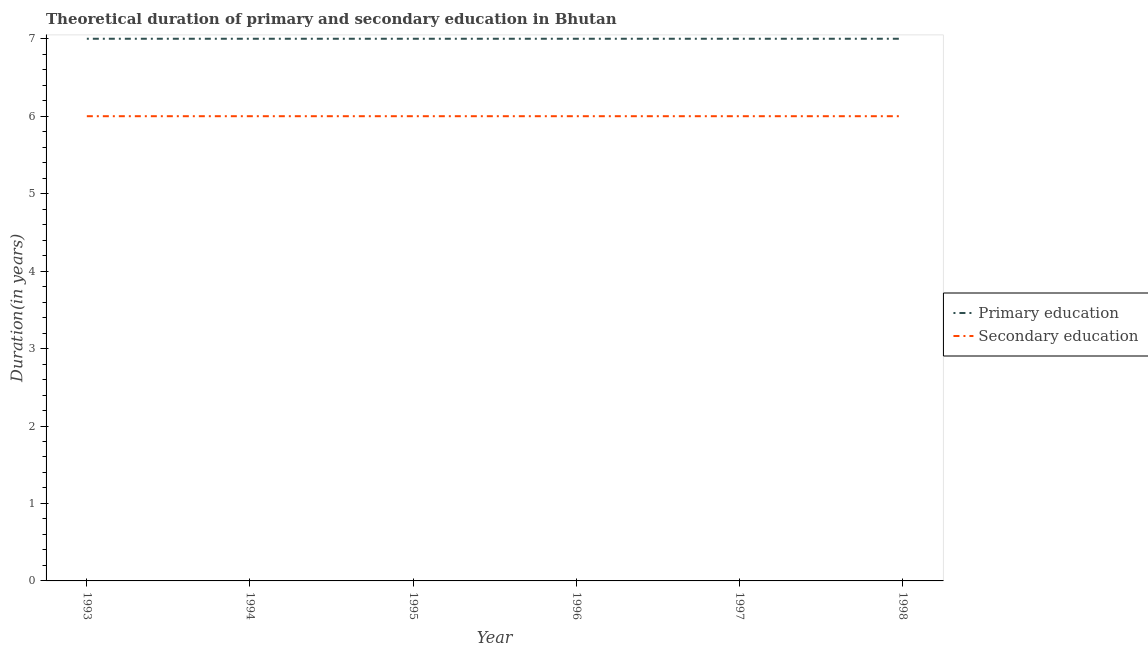How many different coloured lines are there?
Provide a succinct answer. 2. Does the line corresponding to duration of secondary education intersect with the line corresponding to duration of primary education?
Make the answer very short. No. What is the duration of primary education in 1996?
Make the answer very short. 7. In which year was the duration of primary education maximum?
Offer a very short reply. 1993. In which year was the duration of primary education minimum?
Provide a short and direct response. 1993. What is the total duration of primary education in the graph?
Keep it short and to the point. 42. What is the difference between the duration of primary education in 1996 and the duration of secondary education in 1998?
Your answer should be very brief. 1. What is the average duration of secondary education per year?
Your answer should be compact. 6. In the year 1998, what is the difference between the duration of primary education and duration of secondary education?
Make the answer very short. 1. What is the ratio of the duration of primary education in 1995 to that in 1998?
Keep it short and to the point. 1. Is the duration of primary education in 1996 less than that in 1997?
Offer a terse response. No. In how many years, is the duration of primary education greater than the average duration of primary education taken over all years?
Keep it short and to the point. 0. Is the sum of the duration of secondary education in 1993 and 1998 greater than the maximum duration of primary education across all years?
Give a very brief answer. Yes. Does the duration of primary education monotonically increase over the years?
Make the answer very short. No. How many lines are there?
Keep it short and to the point. 2. What is the difference between two consecutive major ticks on the Y-axis?
Provide a succinct answer. 1. Are the values on the major ticks of Y-axis written in scientific E-notation?
Make the answer very short. No. Does the graph contain any zero values?
Make the answer very short. No. Does the graph contain grids?
Provide a succinct answer. No. What is the title of the graph?
Provide a succinct answer. Theoretical duration of primary and secondary education in Bhutan. What is the label or title of the X-axis?
Your answer should be compact. Year. What is the label or title of the Y-axis?
Give a very brief answer. Duration(in years). What is the Duration(in years) of Secondary education in 1993?
Give a very brief answer. 6. What is the Duration(in years) of Primary education in 1994?
Keep it short and to the point. 7. What is the Duration(in years) of Primary education in 1995?
Your answer should be compact. 7. What is the Duration(in years) in Secondary education in 1995?
Offer a terse response. 6. What is the Duration(in years) in Primary education in 1997?
Your response must be concise. 7. Across all years, what is the minimum Duration(in years) of Secondary education?
Your response must be concise. 6. What is the total Duration(in years) in Secondary education in the graph?
Your answer should be very brief. 36. What is the difference between the Duration(in years) of Primary education in 1993 and that in 1994?
Make the answer very short. 0. What is the difference between the Duration(in years) of Primary education in 1993 and that in 1996?
Offer a very short reply. 0. What is the difference between the Duration(in years) of Secondary education in 1993 and that in 1996?
Provide a succinct answer. 0. What is the difference between the Duration(in years) of Secondary education in 1993 and that in 1997?
Your answer should be compact. 0. What is the difference between the Duration(in years) of Primary education in 1993 and that in 1998?
Your answer should be compact. 0. What is the difference between the Duration(in years) of Primary education in 1994 and that in 1995?
Keep it short and to the point. 0. What is the difference between the Duration(in years) of Secondary education in 1994 and that in 1995?
Your answer should be very brief. 0. What is the difference between the Duration(in years) of Primary education in 1995 and that in 1997?
Your response must be concise. 0. What is the difference between the Duration(in years) of Primary education in 1995 and that in 1998?
Your response must be concise. 0. What is the difference between the Duration(in years) in Secondary education in 1995 and that in 1998?
Offer a very short reply. 0. What is the difference between the Duration(in years) in Secondary education in 1996 and that in 1997?
Ensure brevity in your answer.  0. What is the difference between the Duration(in years) of Primary education in 1997 and that in 1998?
Offer a very short reply. 0. What is the difference between the Duration(in years) of Primary education in 1993 and the Duration(in years) of Secondary education in 1996?
Your response must be concise. 1. What is the difference between the Duration(in years) of Primary education in 1993 and the Duration(in years) of Secondary education in 1997?
Keep it short and to the point. 1. What is the difference between the Duration(in years) of Primary education in 1995 and the Duration(in years) of Secondary education in 1997?
Provide a succinct answer. 1. What is the difference between the Duration(in years) in Primary education in 1996 and the Duration(in years) in Secondary education in 1998?
Your answer should be compact. 1. In the year 1995, what is the difference between the Duration(in years) in Primary education and Duration(in years) in Secondary education?
Offer a very short reply. 1. In the year 1998, what is the difference between the Duration(in years) of Primary education and Duration(in years) of Secondary education?
Provide a short and direct response. 1. What is the ratio of the Duration(in years) of Secondary education in 1993 to that in 1994?
Give a very brief answer. 1. What is the ratio of the Duration(in years) in Secondary education in 1993 to that in 1995?
Your answer should be compact. 1. What is the ratio of the Duration(in years) in Secondary education in 1993 to that in 1996?
Offer a terse response. 1. What is the ratio of the Duration(in years) of Secondary education in 1994 to that in 1995?
Keep it short and to the point. 1. What is the ratio of the Duration(in years) in Primary education in 1994 to that in 1996?
Ensure brevity in your answer.  1. What is the ratio of the Duration(in years) of Primary education in 1994 to that in 1997?
Ensure brevity in your answer.  1. What is the ratio of the Duration(in years) in Secondary education in 1994 to that in 1997?
Give a very brief answer. 1. What is the ratio of the Duration(in years) in Secondary education in 1994 to that in 1998?
Offer a terse response. 1. What is the ratio of the Duration(in years) of Secondary education in 1995 to that in 1996?
Make the answer very short. 1. What is the ratio of the Duration(in years) of Primary education in 1995 to that in 1997?
Ensure brevity in your answer.  1. What is the ratio of the Duration(in years) in Primary education in 1995 to that in 1998?
Your answer should be compact. 1. What is the ratio of the Duration(in years) in Secondary education in 1995 to that in 1998?
Give a very brief answer. 1. What is the ratio of the Duration(in years) in Primary education in 1996 to that in 1997?
Keep it short and to the point. 1. What is the ratio of the Duration(in years) in Secondary education in 1996 to that in 1997?
Your answer should be compact. 1. What is the ratio of the Duration(in years) of Secondary education in 1996 to that in 1998?
Give a very brief answer. 1. What is the ratio of the Duration(in years) in Secondary education in 1997 to that in 1998?
Your response must be concise. 1. What is the difference between the highest and the second highest Duration(in years) of Secondary education?
Your response must be concise. 0. 